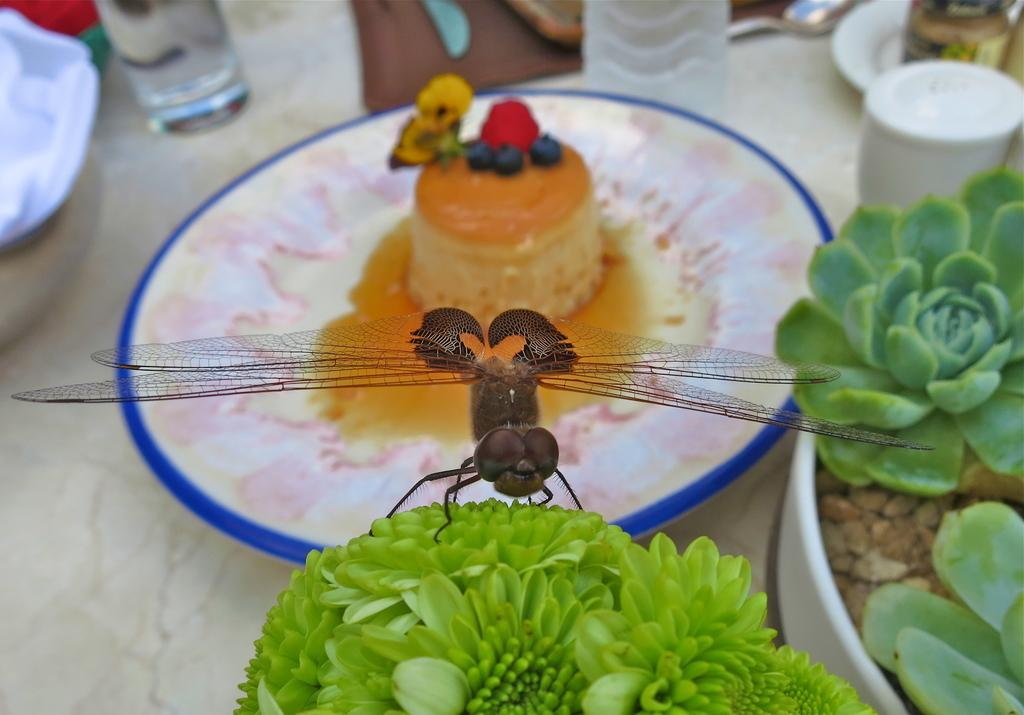What insect can be seen on a plant in the image? There is a dragonfly on a plant in the image. What type of dishware is present in the image? There is a glass in the image. What type of beverage container is present in the image? There is a bottle in the image. What type of decorative elements can be seen in the image? There are garnishes in the image. Where are all of these items located in the image? All of these items are on a table in the image. Can you tell me how many owls are sitting on the train tracks in the image? There are no owls or train tracks present in the image. What type of breath can be seen coming from the dragonfly in the image? There is no breath visible in the image, as dragonflies do not have lungs or the ability to breathe like mammals. 